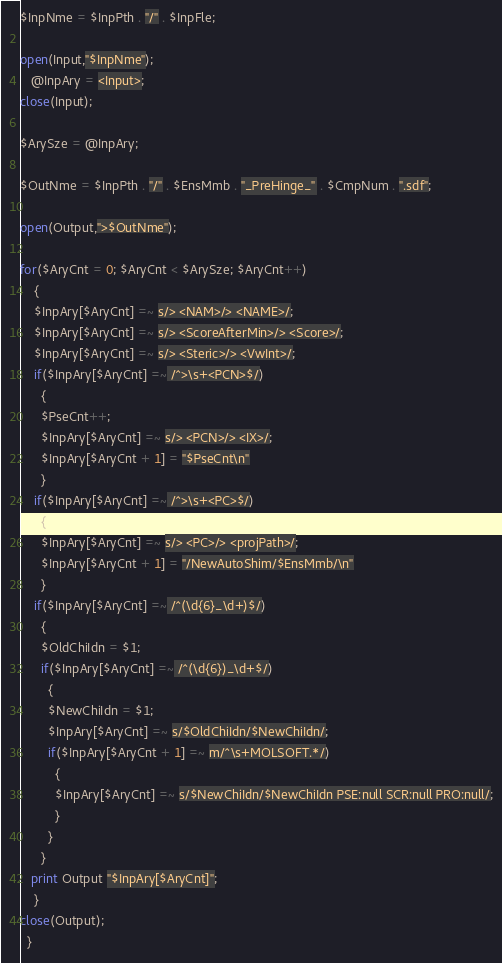<code> <loc_0><loc_0><loc_500><loc_500><_Perl_>$InpNme = $InpPth . "/" . $InpFle;

open(Input,"$InpNme");
   @InpAry = <Input>;
close(Input);

$ArySze = @InpAry;

$OutNme = $InpPth . "/" . $EnsMmb . "_PreHinge_" . $CmpNum . ".sdf";

open(Output,">$OutNme");

for($AryCnt = 0; $AryCnt < $ArySze; $AryCnt++)
    {
    $InpAry[$AryCnt] =~ s/> <NAM>/> <NAME>/;
    $InpAry[$AryCnt] =~ s/> <ScoreAfterMin>/> <Score>/;
    $InpAry[$AryCnt] =~ s/> <Steric>/> <VwInt>/;
    if($InpAry[$AryCnt] =~ /^>\s+<PCN>$/)
      {
      $PseCnt++;
      $InpAry[$AryCnt] =~ s/> <PCN>/> <IX>/;
      $InpAry[$AryCnt + 1] = "$PseCnt\n"    
      }    
    if($InpAry[$AryCnt] =~ /^>\s+<PC>$/)
      {
      $InpAry[$AryCnt] =~ s/> <PC>/> <projPath>/;
      $InpAry[$AryCnt + 1] = "/NewAutoShim/$EnsMmb/\n"
      }
    if($InpAry[$AryCnt] =~ /^(\d{6}_\d+)$/)
      {
      $OldChiIdn = $1;
      if($InpAry[$AryCnt] =~ /^(\d{6})_\d+$/)
        {
        $NewChiIdn = $1;
        $InpAry[$AryCnt] =~ s/$OldChiIdn/$NewChiIdn/;
        if($InpAry[$AryCnt + 1] =~ m/^\s+MOLSOFT.*/)
          {
          $InpAry[$AryCnt] =~ s/$NewChiIdn/$NewChiIdn PSE:null SCR:null PRO:null/;
          }
        }  
      }
   print Output "$InpAry[$AryCnt]";
    }
close(Output);
  }

</code> 